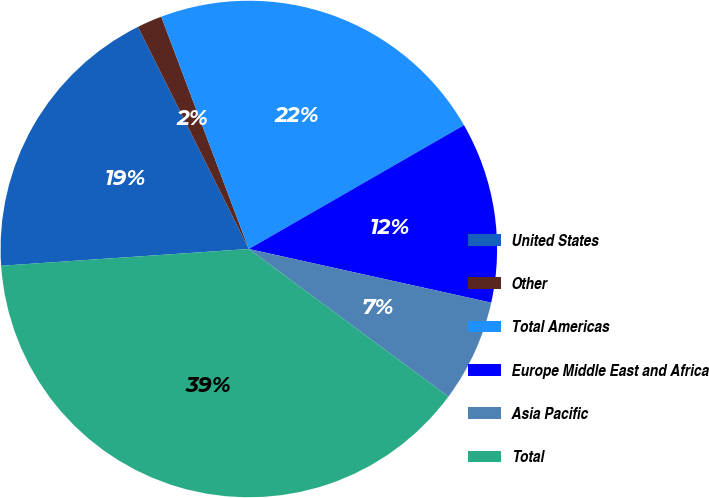<chart> <loc_0><loc_0><loc_500><loc_500><pie_chart><fcel>United States<fcel>Other<fcel>Total Americas<fcel>Europe Middle East and Africa<fcel>Asia Pacific<fcel>Total<nl><fcel>18.71%<fcel>1.63%<fcel>22.43%<fcel>11.78%<fcel>6.67%<fcel>38.79%<nl></chart> 